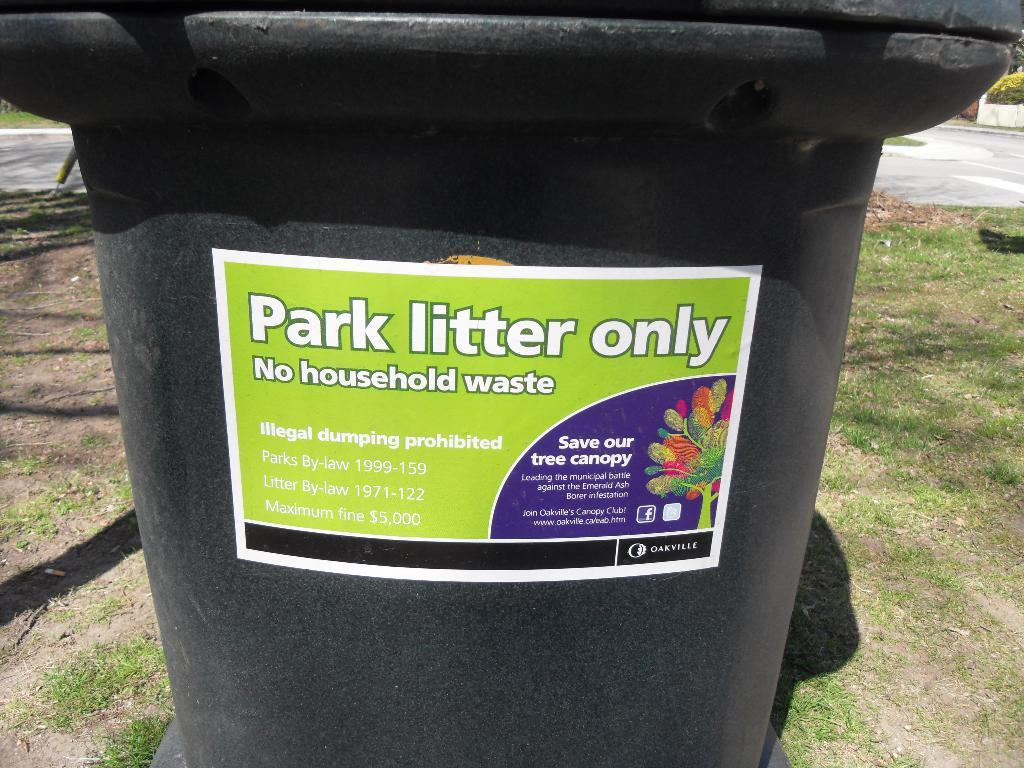Provide a one-sentence caption for the provided image. A plastic can has a sticker that reads, "park litter only.". 